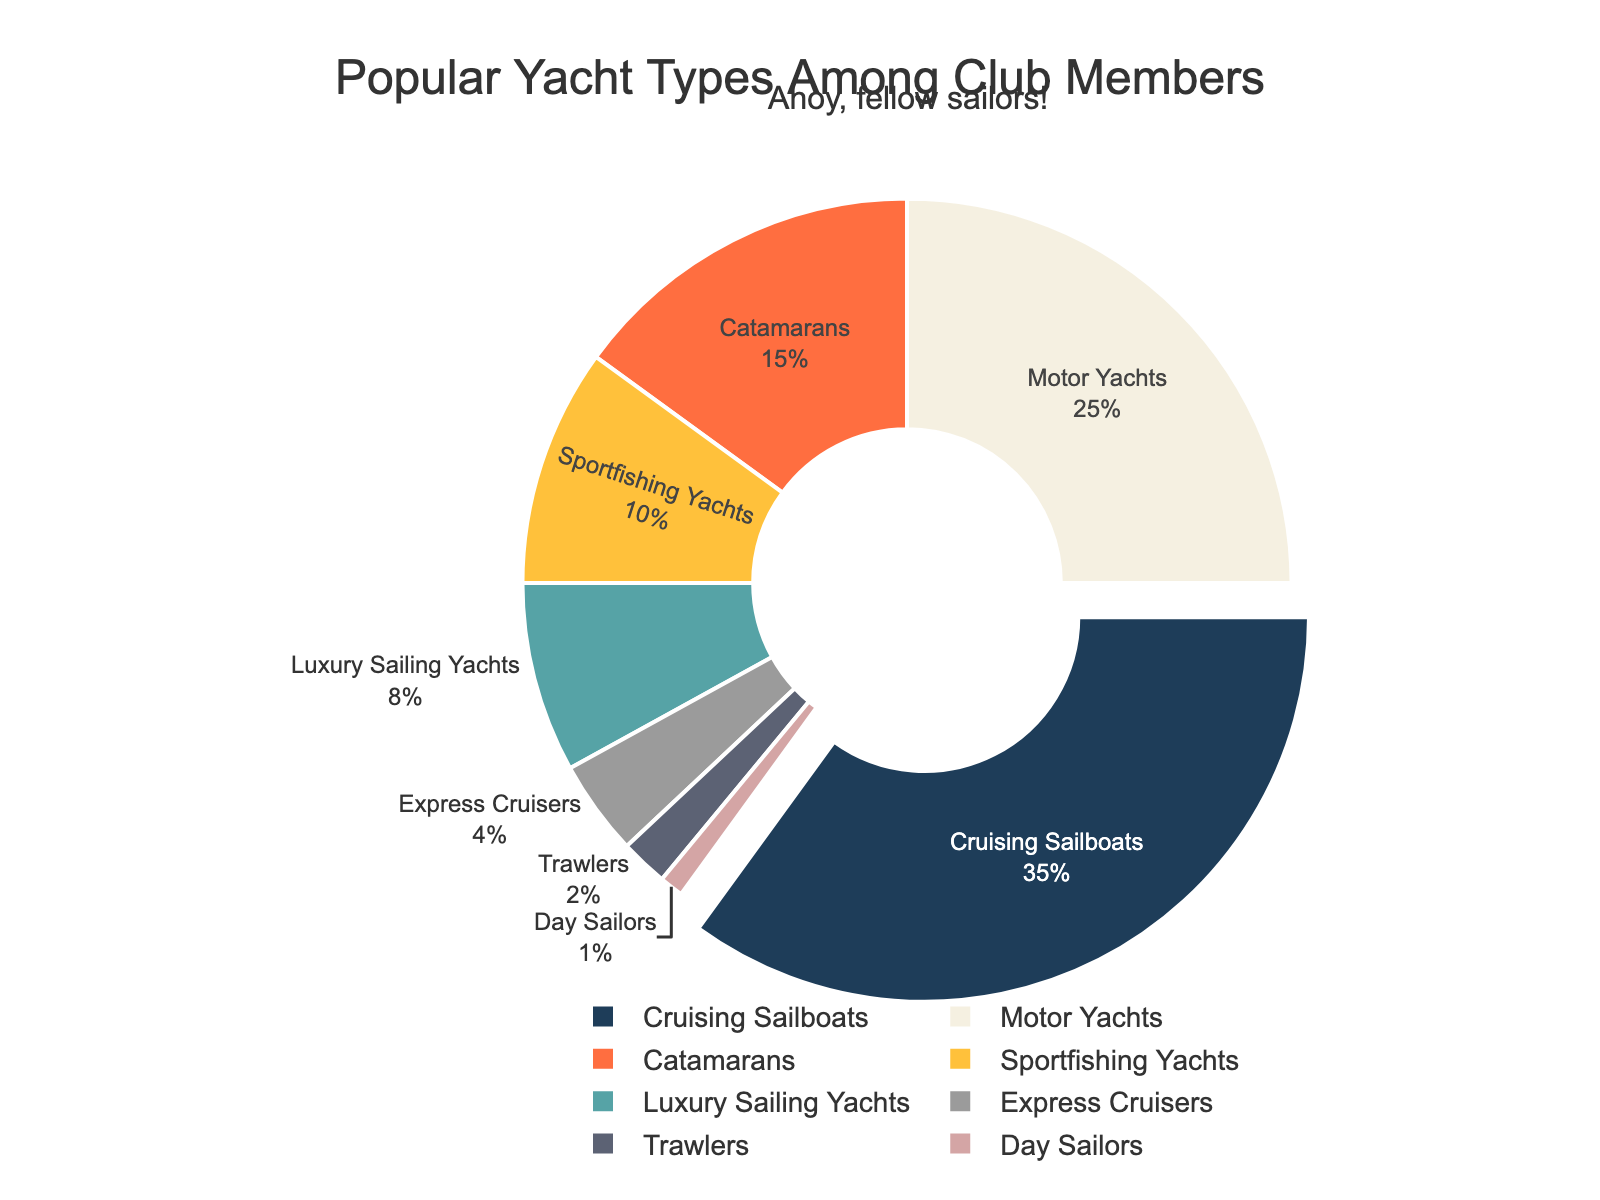What is the most popular yacht type among the club members? The "Cruising Sailboats" section of the pie chart is visually the largest and is pulled out slightly, indicating it is the most popular yacht type.
Answer: Cruising Sailboats Which yacht type is the least popular among the club members? The "Day Sailors" section of the pie chart is the smallest, representing the least percentage.
Answer: Day Sailors What percentage of club members prefers Motor Yachts over Sportfishing Yachts? The pie chart shows that 25% of club members prefer Motor Yachts, while 10% prefer Sportfishing Yachts.
Answer: 25% How much larger is the percentage of members that prefer Cruising Sailboats compared to those preferring Catamarans? The percentage for Cruising Sailboats is 35%, and for Catamarans is 15%. The difference is calculated as 35% - 15%.
Answer: 20% What is the combined percentage of club members who prefer Trawlers and Day Sailors? The pie chart shows Trawlers at 2% and Day Sailors at 1%. Adding these together gives us 2% + 1%.
Answer: 3% Which yacht type has a percentage closest to 10%? The "Sportfishing Yachts" section of the pie chart shows a percentage of 10%, which is exactly 10%.
Answer: Sportfishing Yachts How does the percentage of members preferring Express Cruisers compare to those preferring Catamarans? The pie chart indicates that 4% prefer Express Cruisers and 15% prefer Catamarans. This shows that Catamarans are favored by a higher percentage of members.
Answer: Catamarans are favored more If you combined the percentages of Motor Yachts and Luxury Sailing Yachts, would they surpass the percentage of Cruising Sailboats? The percentage for Motor Yachts is 25% and for Luxury Sailing Yachts is 8%. Combined, this gives 25% + 8% = 33%, which is less than the 35% for Cruising Sailboats.
Answer: No Are there more members preferring Catamarans or those preferring Express Cruisers and Trawlers combined? The pie chart shows Catamarans at 15%, Express Cruisers at 4%, and Trawlers at 2%. Combined, Express Cruisers and Trawlers have 4% + 2% = 6%, which is less than 15% for Catamarans.
Answer: Catamarans What is the second most preferred yacht type among the members? The pie chart indicates that "Motor Yachts" is the second-largest section after "Cruising Sailboats," with 25% of the members' preference.
Answer: Motor Yachts 